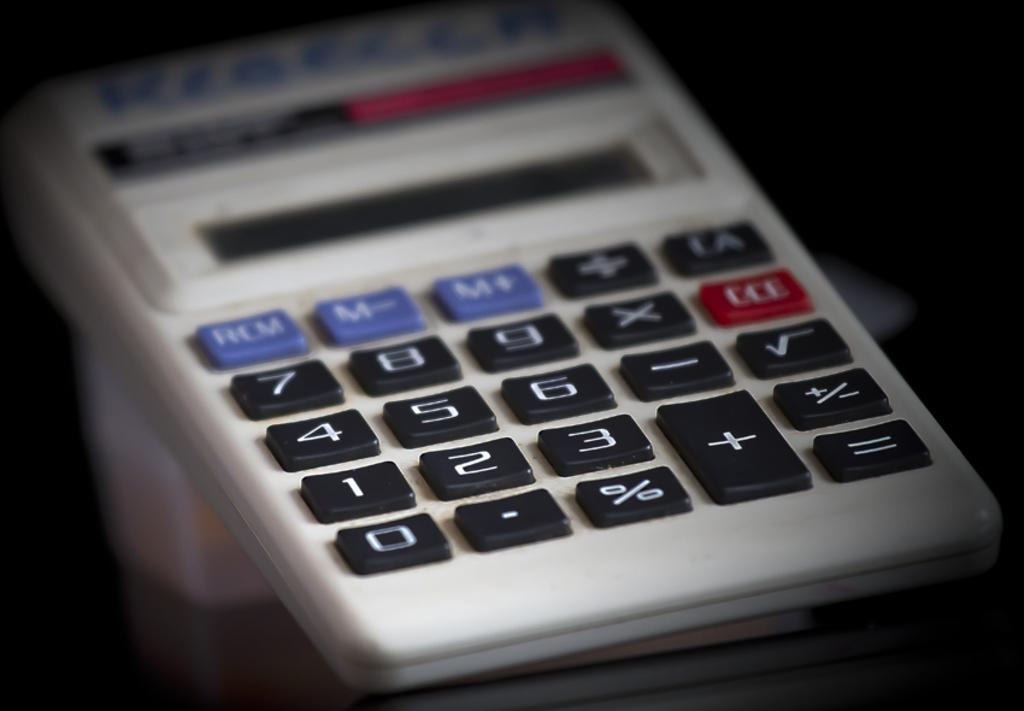Provide a one-sentence caption for the provided image. A small hand held calculater with Kiechler written in marker on the top. 